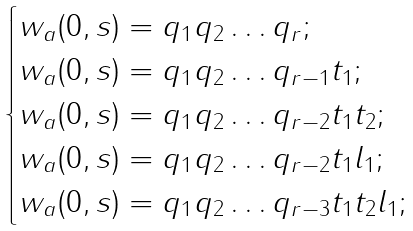<formula> <loc_0><loc_0><loc_500><loc_500>\begin{cases} w _ { a } ( 0 , s ) = q _ { 1 } q _ { 2 } \dots q _ { r } ; \\ w _ { a } ( 0 , s ) = q _ { 1 } q _ { 2 } \dots q _ { r - 1 } t _ { 1 } ; \\ w _ { a } ( 0 , s ) = q _ { 1 } q _ { 2 } \dots q _ { r - 2 } t _ { 1 } t _ { 2 } ; \\ w _ { a } ( 0 , s ) = q _ { 1 } q _ { 2 } \dots q _ { r - 2 } t _ { 1 } l _ { 1 } ; \\ w _ { a } ( 0 , s ) = q _ { 1 } q _ { 2 } \dots q _ { r - 3 } t _ { 1 } t _ { 2 } l _ { 1 } ; \end{cases}</formula> 